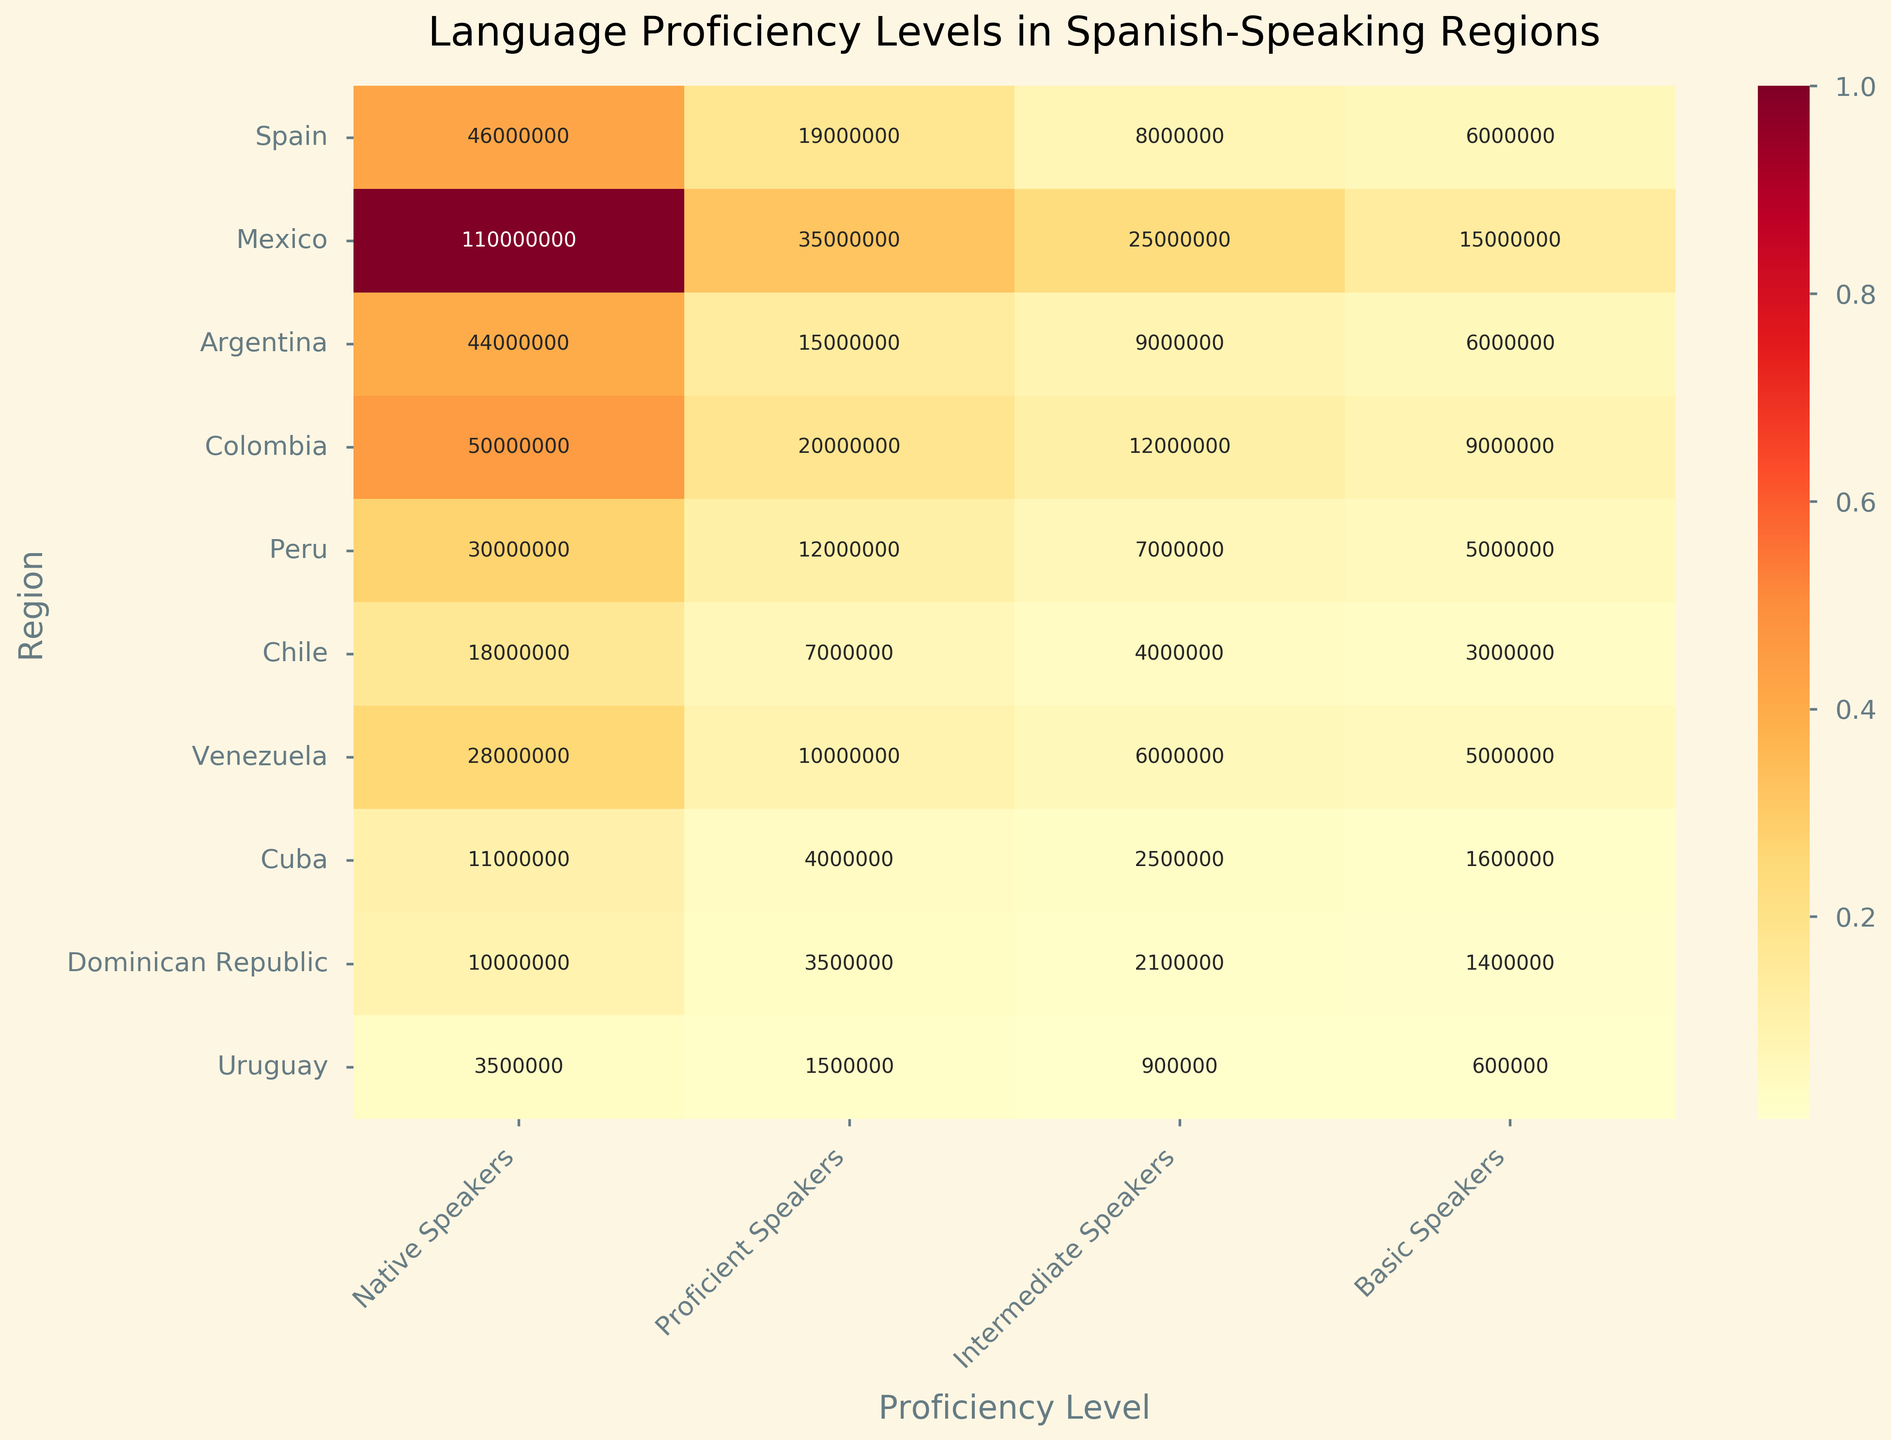What regions are included in the heatmap? The heatmap includes several Spanish-speaking regions. By looking at the y-axis, you can identify the regions listed.
Answer: Spain, Mexico, Argentina, Colombia, Peru, Chile, Venezuela, Cuba, Dominican Republic, Uruguay What proficiency level has the highest number of speakers in Mexico? By examining the values on the heatmap for Mexico, you can identify that the highest number of speakers falls under the 'Native Speakers' category.
Answer: Native Speakers How many proficient speakers are there in Peru? Look at the cell corresponding to 'Proficient Speakers' in the row for Peru to find the number.
Answer: 12000000 Which region has fewer proficient speakers than Colombia? Look at the values under the 'Proficient Speakers' column and compare them to the value for Colombia. Identify the regions with fewer proficient speakers.
Answer: Argentina, Chile, Venezuela, Cuba, Dominican Republic, Uruguay What's the difference in the number of intermediate speakers between Argentina and Colombia? Identify the number of intermediate speakers for both Argentina and Colombia from the heatmap, then subtract the smaller number from the larger one.
Answer: 3000000 (Colombia has 12000000, Argentina has 9000000, the difference is 12000000 - 9000000) Which region has the least number of basic speakers? Scan through the 'Basic Speakers' column and identify the region with the smallest value.
Answer: Uruguay Which region has the most balanced distribution of speakers among all proficiency levels? Evaluate the distribution of speaker numbers across all proficiency levels for each region. Look for the region where the values are most similar to each other across levels.
Answer: Cuba Compare the number of native speakers in Spain to Mexico. Which one has more? Look at the values under 'Native Speakers' for both Spain and Mexico. Compare the two numbers to see which one is greater.
Answer: Mexico How does the number of basic speakers in Chile compare to those in the Dominican Republic? Compare the 'Basic Speakers' values for Chile and the Dominican Republic. Identify which value is greater or if they are equal.
Answer: Chile Find the average number of intermediate speakers in Argentina, Peru, and Chile. Sum the intermediate speaker values for Argentina, Peru, and Chile, then divide by 3 to find the average.
Answer: (9000000 + 7000000 + 4000000)/3 = 6666667 